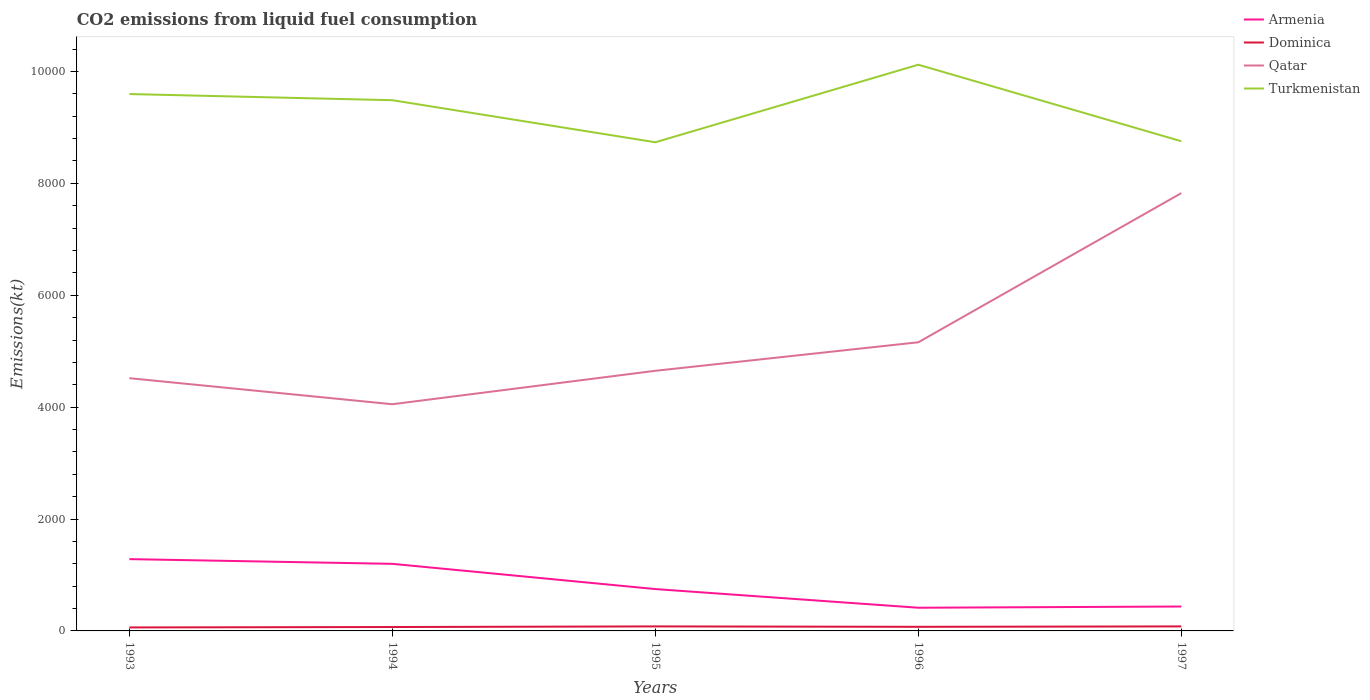Does the line corresponding to Turkmenistan intersect with the line corresponding to Qatar?
Your answer should be compact. No. Is the number of lines equal to the number of legend labels?
Provide a succinct answer. Yes. Across all years, what is the maximum amount of CO2 emitted in Qatar?
Keep it short and to the point. 4052.03. In which year was the amount of CO2 emitted in Dominica maximum?
Provide a short and direct response. 1993. What is the total amount of CO2 emitted in Dominica in the graph?
Make the answer very short. -3.67. What is the difference between the highest and the second highest amount of CO2 emitted in Dominica?
Offer a very short reply. 18.33. How many years are there in the graph?
Offer a terse response. 5. Does the graph contain any zero values?
Ensure brevity in your answer.  No. Where does the legend appear in the graph?
Your response must be concise. Top right. How many legend labels are there?
Your answer should be very brief. 4. How are the legend labels stacked?
Provide a succinct answer. Vertical. What is the title of the graph?
Provide a short and direct response. CO2 emissions from liquid fuel consumption. Does "Slovenia" appear as one of the legend labels in the graph?
Give a very brief answer. No. What is the label or title of the X-axis?
Your answer should be compact. Years. What is the label or title of the Y-axis?
Ensure brevity in your answer.  Emissions(kt). What is the Emissions(kt) in Armenia in 1993?
Your answer should be very brief. 1283.45. What is the Emissions(kt) in Dominica in 1993?
Ensure brevity in your answer.  62.34. What is the Emissions(kt) in Qatar in 1993?
Ensure brevity in your answer.  4517.74. What is the Emissions(kt) in Turkmenistan in 1993?
Your answer should be compact. 9596.54. What is the Emissions(kt) in Armenia in 1994?
Offer a very short reply. 1199.11. What is the Emissions(kt) in Dominica in 1994?
Keep it short and to the point. 69.67. What is the Emissions(kt) of Qatar in 1994?
Your response must be concise. 4052.03. What is the Emissions(kt) in Turkmenistan in 1994?
Offer a terse response. 9486.53. What is the Emissions(kt) of Armenia in 1995?
Your answer should be compact. 748.07. What is the Emissions(kt) of Dominica in 1995?
Offer a terse response. 80.67. What is the Emissions(kt) in Qatar in 1995?
Keep it short and to the point. 4649.76. What is the Emissions(kt) in Turkmenistan in 1995?
Your response must be concise. 8734.79. What is the Emissions(kt) in Armenia in 1996?
Provide a short and direct response. 414.37. What is the Emissions(kt) of Dominica in 1996?
Provide a short and direct response. 73.34. What is the Emissions(kt) in Qatar in 1996?
Make the answer very short. 5159.47. What is the Emissions(kt) in Turkmenistan in 1996?
Your answer should be very brief. 1.01e+04. What is the Emissions(kt) of Armenia in 1997?
Your answer should be compact. 436.37. What is the Emissions(kt) of Dominica in 1997?
Your answer should be compact. 80.67. What is the Emissions(kt) in Qatar in 1997?
Ensure brevity in your answer.  7825.38. What is the Emissions(kt) of Turkmenistan in 1997?
Offer a very short reply. 8753.13. Across all years, what is the maximum Emissions(kt) in Armenia?
Offer a terse response. 1283.45. Across all years, what is the maximum Emissions(kt) in Dominica?
Ensure brevity in your answer.  80.67. Across all years, what is the maximum Emissions(kt) of Qatar?
Give a very brief answer. 7825.38. Across all years, what is the maximum Emissions(kt) of Turkmenistan?
Provide a short and direct response. 1.01e+04. Across all years, what is the minimum Emissions(kt) of Armenia?
Keep it short and to the point. 414.37. Across all years, what is the minimum Emissions(kt) in Dominica?
Keep it short and to the point. 62.34. Across all years, what is the minimum Emissions(kt) of Qatar?
Give a very brief answer. 4052.03. Across all years, what is the minimum Emissions(kt) in Turkmenistan?
Your answer should be compact. 8734.79. What is the total Emissions(kt) in Armenia in the graph?
Provide a short and direct response. 4081.37. What is the total Emissions(kt) in Dominica in the graph?
Your response must be concise. 366.7. What is the total Emissions(kt) in Qatar in the graph?
Your response must be concise. 2.62e+04. What is the total Emissions(kt) of Turkmenistan in the graph?
Provide a succinct answer. 4.67e+04. What is the difference between the Emissions(kt) in Armenia in 1993 and that in 1994?
Provide a short and direct response. 84.34. What is the difference between the Emissions(kt) of Dominica in 1993 and that in 1994?
Your response must be concise. -7.33. What is the difference between the Emissions(kt) of Qatar in 1993 and that in 1994?
Offer a very short reply. 465.71. What is the difference between the Emissions(kt) of Turkmenistan in 1993 and that in 1994?
Provide a succinct answer. 110.01. What is the difference between the Emissions(kt) in Armenia in 1993 and that in 1995?
Your answer should be very brief. 535.38. What is the difference between the Emissions(kt) in Dominica in 1993 and that in 1995?
Provide a succinct answer. -18.34. What is the difference between the Emissions(kt) in Qatar in 1993 and that in 1995?
Make the answer very short. -132.01. What is the difference between the Emissions(kt) in Turkmenistan in 1993 and that in 1995?
Your response must be concise. 861.75. What is the difference between the Emissions(kt) of Armenia in 1993 and that in 1996?
Make the answer very short. 869.08. What is the difference between the Emissions(kt) in Dominica in 1993 and that in 1996?
Ensure brevity in your answer.  -11. What is the difference between the Emissions(kt) of Qatar in 1993 and that in 1996?
Your answer should be very brief. -641.73. What is the difference between the Emissions(kt) of Turkmenistan in 1993 and that in 1996?
Give a very brief answer. -524.38. What is the difference between the Emissions(kt) of Armenia in 1993 and that in 1997?
Ensure brevity in your answer.  847.08. What is the difference between the Emissions(kt) in Dominica in 1993 and that in 1997?
Your response must be concise. -18.34. What is the difference between the Emissions(kt) of Qatar in 1993 and that in 1997?
Your answer should be very brief. -3307.63. What is the difference between the Emissions(kt) in Turkmenistan in 1993 and that in 1997?
Provide a short and direct response. 843.41. What is the difference between the Emissions(kt) of Armenia in 1994 and that in 1995?
Your answer should be very brief. 451.04. What is the difference between the Emissions(kt) of Dominica in 1994 and that in 1995?
Make the answer very short. -11. What is the difference between the Emissions(kt) of Qatar in 1994 and that in 1995?
Keep it short and to the point. -597.72. What is the difference between the Emissions(kt) of Turkmenistan in 1994 and that in 1995?
Make the answer very short. 751.74. What is the difference between the Emissions(kt) of Armenia in 1994 and that in 1996?
Provide a succinct answer. 784.74. What is the difference between the Emissions(kt) in Dominica in 1994 and that in 1996?
Make the answer very short. -3.67. What is the difference between the Emissions(kt) of Qatar in 1994 and that in 1996?
Your answer should be very brief. -1107.43. What is the difference between the Emissions(kt) in Turkmenistan in 1994 and that in 1996?
Keep it short and to the point. -634.39. What is the difference between the Emissions(kt) of Armenia in 1994 and that in 1997?
Provide a short and direct response. 762.74. What is the difference between the Emissions(kt) of Dominica in 1994 and that in 1997?
Offer a terse response. -11. What is the difference between the Emissions(kt) of Qatar in 1994 and that in 1997?
Your answer should be very brief. -3773.34. What is the difference between the Emissions(kt) of Turkmenistan in 1994 and that in 1997?
Provide a succinct answer. 733.4. What is the difference between the Emissions(kt) in Armenia in 1995 and that in 1996?
Give a very brief answer. 333.7. What is the difference between the Emissions(kt) in Dominica in 1995 and that in 1996?
Make the answer very short. 7.33. What is the difference between the Emissions(kt) in Qatar in 1995 and that in 1996?
Keep it short and to the point. -509.71. What is the difference between the Emissions(kt) of Turkmenistan in 1995 and that in 1996?
Give a very brief answer. -1386.13. What is the difference between the Emissions(kt) of Armenia in 1995 and that in 1997?
Offer a very short reply. 311.69. What is the difference between the Emissions(kt) in Dominica in 1995 and that in 1997?
Provide a succinct answer. 0. What is the difference between the Emissions(kt) of Qatar in 1995 and that in 1997?
Give a very brief answer. -3175.62. What is the difference between the Emissions(kt) in Turkmenistan in 1995 and that in 1997?
Make the answer very short. -18.34. What is the difference between the Emissions(kt) of Armenia in 1996 and that in 1997?
Make the answer very short. -22. What is the difference between the Emissions(kt) of Dominica in 1996 and that in 1997?
Offer a very short reply. -7.33. What is the difference between the Emissions(kt) in Qatar in 1996 and that in 1997?
Make the answer very short. -2665.91. What is the difference between the Emissions(kt) of Turkmenistan in 1996 and that in 1997?
Make the answer very short. 1367.79. What is the difference between the Emissions(kt) in Armenia in 1993 and the Emissions(kt) in Dominica in 1994?
Provide a short and direct response. 1213.78. What is the difference between the Emissions(kt) in Armenia in 1993 and the Emissions(kt) in Qatar in 1994?
Keep it short and to the point. -2768.59. What is the difference between the Emissions(kt) of Armenia in 1993 and the Emissions(kt) of Turkmenistan in 1994?
Offer a terse response. -8203.08. What is the difference between the Emissions(kt) of Dominica in 1993 and the Emissions(kt) of Qatar in 1994?
Your answer should be compact. -3989.7. What is the difference between the Emissions(kt) of Dominica in 1993 and the Emissions(kt) of Turkmenistan in 1994?
Provide a short and direct response. -9424.19. What is the difference between the Emissions(kt) of Qatar in 1993 and the Emissions(kt) of Turkmenistan in 1994?
Offer a very short reply. -4968.78. What is the difference between the Emissions(kt) in Armenia in 1993 and the Emissions(kt) in Dominica in 1995?
Your answer should be compact. 1202.78. What is the difference between the Emissions(kt) of Armenia in 1993 and the Emissions(kt) of Qatar in 1995?
Your answer should be very brief. -3366.31. What is the difference between the Emissions(kt) of Armenia in 1993 and the Emissions(kt) of Turkmenistan in 1995?
Keep it short and to the point. -7451.34. What is the difference between the Emissions(kt) in Dominica in 1993 and the Emissions(kt) in Qatar in 1995?
Offer a terse response. -4587.42. What is the difference between the Emissions(kt) of Dominica in 1993 and the Emissions(kt) of Turkmenistan in 1995?
Offer a very short reply. -8672.45. What is the difference between the Emissions(kt) of Qatar in 1993 and the Emissions(kt) of Turkmenistan in 1995?
Give a very brief answer. -4217.05. What is the difference between the Emissions(kt) of Armenia in 1993 and the Emissions(kt) of Dominica in 1996?
Your answer should be very brief. 1210.11. What is the difference between the Emissions(kt) in Armenia in 1993 and the Emissions(kt) in Qatar in 1996?
Your answer should be very brief. -3876.02. What is the difference between the Emissions(kt) in Armenia in 1993 and the Emissions(kt) in Turkmenistan in 1996?
Offer a very short reply. -8837.47. What is the difference between the Emissions(kt) of Dominica in 1993 and the Emissions(kt) of Qatar in 1996?
Your answer should be very brief. -5097.13. What is the difference between the Emissions(kt) of Dominica in 1993 and the Emissions(kt) of Turkmenistan in 1996?
Keep it short and to the point. -1.01e+04. What is the difference between the Emissions(kt) of Qatar in 1993 and the Emissions(kt) of Turkmenistan in 1996?
Offer a terse response. -5603.18. What is the difference between the Emissions(kt) of Armenia in 1993 and the Emissions(kt) of Dominica in 1997?
Your answer should be very brief. 1202.78. What is the difference between the Emissions(kt) of Armenia in 1993 and the Emissions(kt) of Qatar in 1997?
Keep it short and to the point. -6541.93. What is the difference between the Emissions(kt) in Armenia in 1993 and the Emissions(kt) in Turkmenistan in 1997?
Your answer should be very brief. -7469.68. What is the difference between the Emissions(kt) of Dominica in 1993 and the Emissions(kt) of Qatar in 1997?
Offer a terse response. -7763.04. What is the difference between the Emissions(kt) in Dominica in 1993 and the Emissions(kt) in Turkmenistan in 1997?
Give a very brief answer. -8690.79. What is the difference between the Emissions(kt) in Qatar in 1993 and the Emissions(kt) in Turkmenistan in 1997?
Make the answer very short. -4235.39. What is the difference between the Emissions(kt) of Armenia in 1994 and the Emissions(kt) of Dominica in 1995?
Provide a succinct answer. 1118.43. What is the difference between the Emissions(kt) of Armenia in 1994 and the Emissions(kt) of Qatar in 1995?
Give a very brief answer. -3450.65. What is the difference between the Emissions(kt) of Armenia in 1994 and the Emissions(kt) of Turkmenistan in 1995?
Your answer should be compact. -7535.69. What is the difference between the Emissions(kt) in Dominica in 1994 and the Emissions(kt) in Qatar in 1995?
Your answer should be compact. -4580.08. What is the difference between the Emissions(kt) of Dominica in 1994 and the Emissions(kt) of Turkmenistan in 1995?
Provide a short and direct response. -8665.12. What is the difference between the Emissions(kt) in Qatar in 1994 and the Emissions(kt) in Turkmenistan in 1995?
Your response must be concise. -4682.76. What is the difference between the Emissions(kt) in Armenia in 1994 and the Emissions(kt) in Dominica in 1996?
Keep it short and to the point. 1125.77. What is the difference between the Emissions(kt) in Armenia in 1994 and the Emissions(kt) in Qatar in 1996?
Give a very brief answer. -3960.36. What is the difference between the Emissions(kt) of Armenia in 1994 and the Emissions(kt) of Turkmenistan in 1996?
Your answer should be very brief. -8921.81. What is the difference between the Emissions(kt) of Dominica in 1994 and the Emissions(kt) of Qatar in 1996?
Provide a succinct answer. -5089.8. What is the difference between the Emissions(kt) in Dominica in 1994 and the Emissions(kt) in Turkmenistan in 1996?
Keep it short and to the point. -1.01e+04. What is the difference between the Emissions(kt) in Qatar in 1994 and the Emissions(kt) in Turkmenistan in 1996?
Your answer should be very brief. -6068.89. What is the difference between the Emissions(kt) of Armenia in 1994 and the Emissions(kt) of Dominica in 1997?
Provide a short and direct response. 1118.43. What is the difference between the Emissions(kt) in Armenia in 1994 and the Emissions(kt) in Qatar in 1997?
Offer a terse response. -6626.27. What is the difference between the Emissions(kt) in Armenia in 1994 and the Emissions(kt) in Turkmenistan in 1997?
Make the answer very short. -7554.02. What is the difference between the Emissions(kt) of Dominica in 1994 and the Emissions(kt) of Qatar in 1997?
Your response must be concise. -7755.7. What is the difference between the Emissions(kt) of Dominica in 1994 and the Emissions(kt) of Turkmenistan in 1997?
Your answer should be compact. -8683.46. What is the difference between the Emissions(kt) in Qatar in 1994 and the Emissions(kt) in Turkmenistan in 1997?
Your answer should be compact. -4701.09. What is the difference between the Emissions(kt) of Armenia in 1995 and the Emissions(kt) of Dominica in 1996?
Ensure brevity in your answer.  674.73. What is the difference between the Emissions(kt) of Armenia in 1995 and the Emissions(kt) of Qatar in 1996?
Ensure brevity in your answer.  -4411.4. What is the difference between the Emissions(kt) of Armenia in 1995 and the Emissions(kt) of Turkmenistan in 1996?
Your answer should be compact. -9372.85. What is the difference between the Emissions(kt) in Dominica in 1995 and the Emissions(kt) in Qatar in 1996?
Ensure brevity in your answer.  -5078.8. What is the difference between the Emissions(kt) of Dominica in 1995 and the Emissions(kt) of Turkmenistan in 1996?
Provide a short and direct response. -1.00e+04. What is the difference between the Emissions(kt) in Qatar in 1995 and the Emissions(kt) in Turkmenistan in 1996?
Offer a very short reply. -5471.16. What is the difference between the Emissions(kt) in Armenia in 1995 and the Emissions(kt) in Dominica in 1997?
Make the answer very short. 667.39. What is the difference between the Emissions(kt) in Armenia in 1995 and the Emissions(kt) in Qatar in 1997?
Your answer should be compact. -7077.31. What is the difference between the Emissions(kt) of Armenia in 1995 and the Emissions(kt) of Turkmenistan in 1997?
Your response must be concise. -8005.06. What is the difference between the Emissions(kt) in Dominica in 1995 and the Emissions(kt) in Qatar in 1997?
Your answer should be compact. -7744.7. What is the difference between the Emissions(kt) of Dominica in 1995 and the Emissions(kt) of Turkmenistan in 1997?
Your answer should be very brief. -8672.45. What is the difference between the Emissions(kt) in Qatar in 1995 and the Emissions(kt) in Turkmenistan in 1997?
Give a very brief answer. -4103.37. What is the difference between the Emissions(kt) in Armenia in 1996 and the Emissions(kt) in Dominica in 1997?
Your answer should be compact. 333.7. What is the difference between the Emissions(kt) of Armenia in 1996 and the Emissions(kt) of Qatar in 1997?
Provide a short and direct response. -7411.01. What is the difference between the Emissions(kt) of Armenia in 1996 and the Emissions(kt) of Turkmenistan in 1997?
Your answer should be very brief. -8338.76. What is the difference between the Emissions(kt) in Dominica in 1996 and the Emissions(kt) in Qatar in 1997?
Provide a short and direct response. -7752.04. What is the difference between the Emissions(kt) in Dominica in 1996 and the Emissions(kt) in Turkmenistan in 1997?
Make the answer very short. -8679.79. What is the difference between the Emissions(kt) of Qatar in 1996 and the Emissions(kt) of Turkmenistan in 1997?
Keep it short and to the point. -3593.66. What is the average Emissions(kt) in Armenia per year?
Your answer should be compact. 816.27. What is the average Emissions(kt) of Dominica per year?
Make the answer very short. 73.34. What is the average Emissions(kt) of Qatar per year?
Provide a succinct answer. 5240.88. What is the average Emissions(kt) in Turkmenistan per year?
Keep it short and to the point. 9338.38. In the year 1993, what is the difference between the Emissions(kt) of Armenia and Emissions(kt) of Dominica?
Offer a terse response. 1221.11. In the year 1993, what is the difference between the Emissions(kt) in Armenia and Emissions(kt) in Qatar?
Offer a terse response. -3234.29. In the year 1993, what is the difference between the Emissions(kt) of Armenia and Emissions(kt) of Turkmenistan?
Ensure brevity in your answer.  -8313.09. In the year 1993, what is the difference between the Emissions(kt) of Dominica and Emissions(kt) of Qatar?
Provide a short and direct response. -4455.4. In the year 1993, what is the difference between the Emissions(kt) of Dominica and Emissions(kt) of Turkmenistan?
Your answer should be very brief. -9534.2. In the year 1993, what is the difference between the Emissions(kt) in Qatar and Emissions(kt) in Turkmenistan?
Your answer should be compact. -5078.8. In the year 1994, what is the difference between the Emissions(kt) in Armenia and Emissions(kt) in Dominica?
Your answer should be very brief. 1129.44. In the year 1994, what is the difference between the Emissions(kt) of Armenia and Emissions(kt) of Qatar?
Make the answer very short. -2852.93. In the year 1994, what is the difference between the Emissions(kt) of Armenia and Emissions(kt) of Turkmenistan?
Keep it short and to the point. -8287.42. In the year 1994, what is the difference between the Emissions(kt) in Dominica and Emissions(kt) in Qatar?
Offer a very short reply. -3982.36. In the year 1994, what is the difference between the Emissions(kt) of Dominica and Emissions(kt) of Turkmenistan?
Provide a succinct answer. -9416.86. In the year 1994, what is the difference between the Emissions(kt) in Qatar and Emissions(kt) in Turkmenistan?
Give a very brief answer. -5434.49. In the year 1995, what is the difference between the Emissions(kt) of Armenia and Emissions(kt) of Dominica?
Your answer should be very brief. 667.39. In the year 1995, what is the difference between the Emissions(kt) of Armenia and Emissions(kt) of Qatar?
Provide a short and direct response. -3901.69. In the year 1995, what is the difference between the Emissions(kt) of Armenia and Emissions(kt) of Turkmenistan?
Provide a short and direct response. -7986.73. In the year 1995, what is the difference between the Emissions(kt) of Dominica and Emissions(kt) of Qatar?
Provide a succinct answer. -4569.08. In the year 1995, what is the difference between the Emissions(kt) of Dominica and Emissions(kt) of Turkmenistan?
Your answer should be compact. -8654.12. In the year 1995, what is the difference between the Emissions(kt) of Qatar and Emissions(kt) of Turkmenistan?
Your answer should be very brief. -4085.04. In the year 1996, what is the difference between the Emissions(kt) of Armenia and Emissions(kt) of Dominica?
Your answer should be compact. 341.03. In the year 1996, what is the difference between the Emissions(kt) of Armenia and Emissions(kt) of Qatar?
Your response must be concise. -4745.1. In the year 1996, what is the difference between the Emissions(kt) of Armenia and Emissions(kt) of Turkmenistan?
Your answer should be compact. -9706.55. In the year 1996, what is the difference between the Emissions(kt) of Dominica and Emissions(kt) of Qatar?
Keep it short and to the point. -5086.13. In the year 1996, what is the difference between the Emissions(kt) of Dominica and Emissions(kt) of Turkmenistan?
Give a very brief answer. -1.00e+04. In the year 1996, what is the difference between the Emissions(kt) in Qatar and Emissions(kt) in Turkmenistan?
Offer a very short reply. -4961.45. In the year 1997, what is the difference between the Emissions(kt) of Armenia and Emissions(kt) of Dominica?
Offer a terse response. 355.7. In the year 1997, what is the difference between the Emissions(kt) in Armenia and Emissions(kt) in Qatar?
Ensure brevity in your answer.  -7389.01. In the year 1997, what is the difference between the Emissions(kt) of Armenia and Emissions(kt) of Turkmenistan?
Provide a succinct answer. -8316.76. In the year 1997, what is the difference between the Emissions(kt) of Dominica and Emissions(kt) of Qatar?
Offer a very short reply. -7744.7. In the year 1997, what is the difference between the Emissions(kt) of Dominica and Emissions(kt) of Turkmenistan?
Ensure brevity in your answer.  -8672.45. In the year 1997, what is the difference between the Emissions(kt) in Qatar and Emissions(kt) in Turkmenistan?
Provide a succinct answer. -927.75. What is the ratio of the Emissions(kt) in Armenia in 1993 to that in 1994?
Make the answer very short. 1.07. What is the ratio of the Emissions(kt) of Dominica in 1993 to that in 1994?
Your answer should be very brief. 0.89. What is the ratio of the Emissions(kt) in Qatar in 1993 to that in 1994?
Offer a very short reply. 1.11. What is the ratio of the Emissions(kt) in Turkmenistan in 1993 to that in 1994?
Make the answer very short. 1.01. What is the ratio of the Emissions(kt) in Armenia in 1993 to that in 1995?
Your answer should be compact. 1.72. What is the ratio of the Emissions(kt) of Dominica in 1993 to that in 1995?
Your response must be concise. 0.77. What is the ratio of the Emissions(kt) in Qatar in 1993 to that in 1995?
Offer a very short reply. 0.97. What is the ratio of the Emissions(kt) in Turkmenistan in 1993 to that in 1995?
Your response must be concise. 1.1. What is the ratio of the Emissions(kt) of Armenia in 1993 to that in 1996?
Your answer should be compact. 3.1. What is the ratio of the Emissions(kt) of Dominica in 1993 to that in 1996?
Give a very brief answer. 0.85. What is the ratio of the Emissions(kt) in Qatar in 1993 to that in 1996?
Your response must be concise. 0.88. What is the ratio of the Emissions(kt) of Turkmenistan in 1993 to that in 1996?
Keep it short and to the point. 0.95. What is the ratio of the Emissions(kt) of Armenia in 1993 to that in 1997?
Provide a succinct answer. 2.94. What is the ratio of the Emissions(kt) in Dominica in 1993 to that in 1997?
Offer a very short reply. 0.77. What is the ratio of the Emissions(kt) of Qatar in 1993 to that in 1997?
Offer a terse response. 0.58. What is the ratio of the Emissions(kt) of Turkmenistan in 1993 to that in 1997?
Your response must be concise. 1.1. What is the ratio of the Emissions(kt) in Armenia in 1994 to that in 1995?
Make the answer very short. 1.6. What is the ratio of the Emissions(kt) in Dominica in 1994 to that in 1995?
Your response must be concise. 0.86. What is the ratio of the Emissions(kt) of Qatar in 1994 to that in 1995?
Offer a terse response. 0.87. What is the ratio of the Emissions(kt) in Turkmenistan in 1994 to that in 1995?
Your answer should be compact. 1.09. What is the ratio of the Emissions(kt) in Armenia in 1994 to that in 1996?
Make the answer very short. 2.89. What is the ratio of the Emissions(kt) of Qatar in 1994 to that in 1996?
Give a very brief answer. 0.79. What is the ratio of the Emissions(kt) of Turkmenistan in 1994 to that in 1996?
Provide a short and direct response. 0.94. What is the ratio of the Emissions(kt) of Armenia in 1994 to that in 1997?
Give a very brief answer. 2.75. What is the ratio of the Emissions(kt) in Dominica in 1994 to that in 1997?
Your response must be concise. 0.86. What is the ratio of the Emissions(kt) in Qatar in 1994 to that in 1997?
Ensure brevity in your answer.  0.52. What is the ratio of the Emissions(kt) of Turkmenistan in 1994 to that in 1997?
Offer a very short reply. 1.08. What is the ratio of the Emissions(kt) of Armenia in 1995 to that in 1996?
Your response must be concise. 1.81. What is the ratio of the Emissions(kt) in Qatar in 1995 to that in 1996?
Provide a short and direct response. 0.9. What is the ratio of the Emissions(kt) in Turkmenistan in 1995 to that in 1996?
Keep it short and to the point. 0.86. What is the ratio of the Emissions(kt) in Armenia in 1995 to that in 1997?
Offer a terse response. 1.71. What is the ratio of the Emissions(kt) in Qatar in 1995 to that in 1997?
Provide a succinct answer. 0.59. What is the ratio of the Emissions(kt) in Armenia in 1996 to that in 1997?
Make the answer very short. 0.95. What is the ratio of the Emissions(kt) in Dominica in 1996 to that in 1997?
Provide a succinct answer. 0.91. What is the ratio of the Emissions(kt) in Qatar in 1996 to that in 1997?
Offer a very short reply. 0.66. What is the ratio of the Emissions(kt) of Turkmenistan in 1996 to that in 1997?
Keep it short and to the point. 1.16. What is the difference between the highest and the second highest Emissions(kt) in Armenia?
Provide a short and direct response. 84.34. What is the difference between the highest and the second highest Emissions(kt) in Dominica?
Offer a very short reply. 0. What is the difference between the highest and the second highest Emissions(kt) in Qatar?
Your response must be concise. 2665.91. What is the difference between the highest and the second highest Emissions(kt) in Turkmenistan?
Your answer should be very brief. 524.38. What is the difference between the highest and the lowest Emissions(kt) in Armenia?
Provide a succinct answer. 869.08. What is the difference between the highest and the lowest Emissions(kt) of Dominica?
Ensure brevity in your answer.  18.34. What is the difference between the highest and the lowest Emissions(kt) in Qatar?
Offer a terse response. 3773.34. What is the difference between the highest and the lowest Emissions(kt) in Turkmenistan?
Give a very brief answer. 1386.13. 